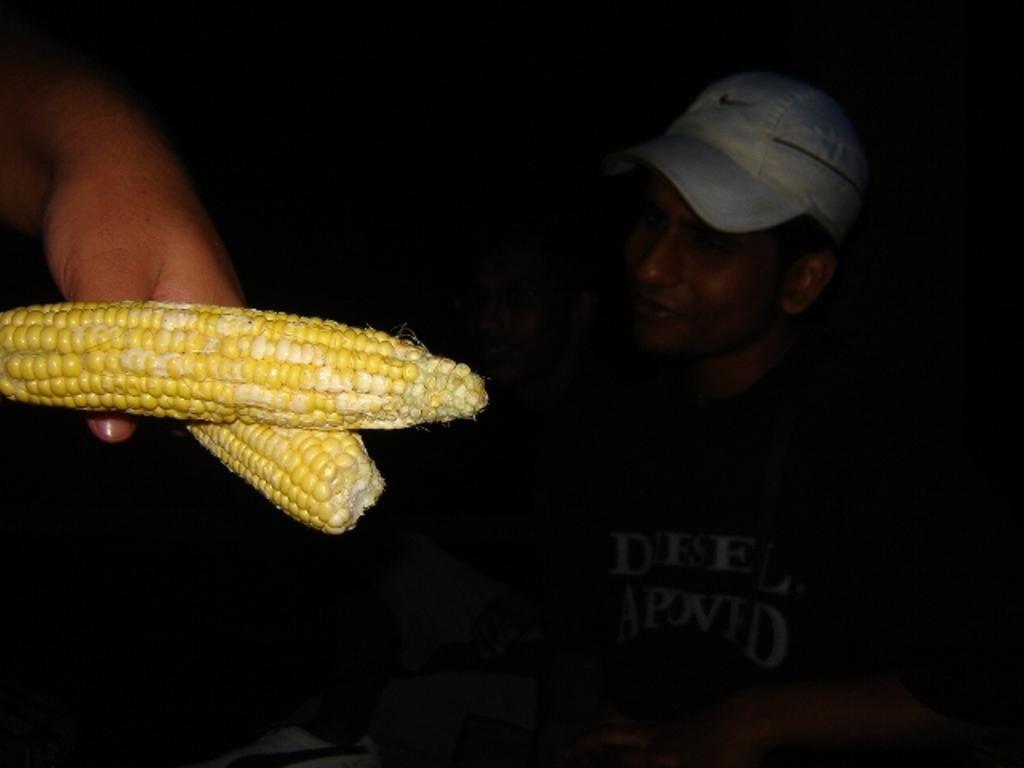Who or what is present in the image? There is a person in the image. What part of the person's body can be seen? The person's hand is visible in the image. What type of food is in the image? There is yellow corn in the image. Can you describe the surroundings of the person? There are people in the background of the image. What is the person wearing on their head? The man is wearing a cap. What type of cloth is being used for expansion in the image? There is no cloth or expansion present in the image. Can you describe the goose that is interacting with the person in the image? There is no goose present in the image; it only features a person, yellow corn, and people in the background. 